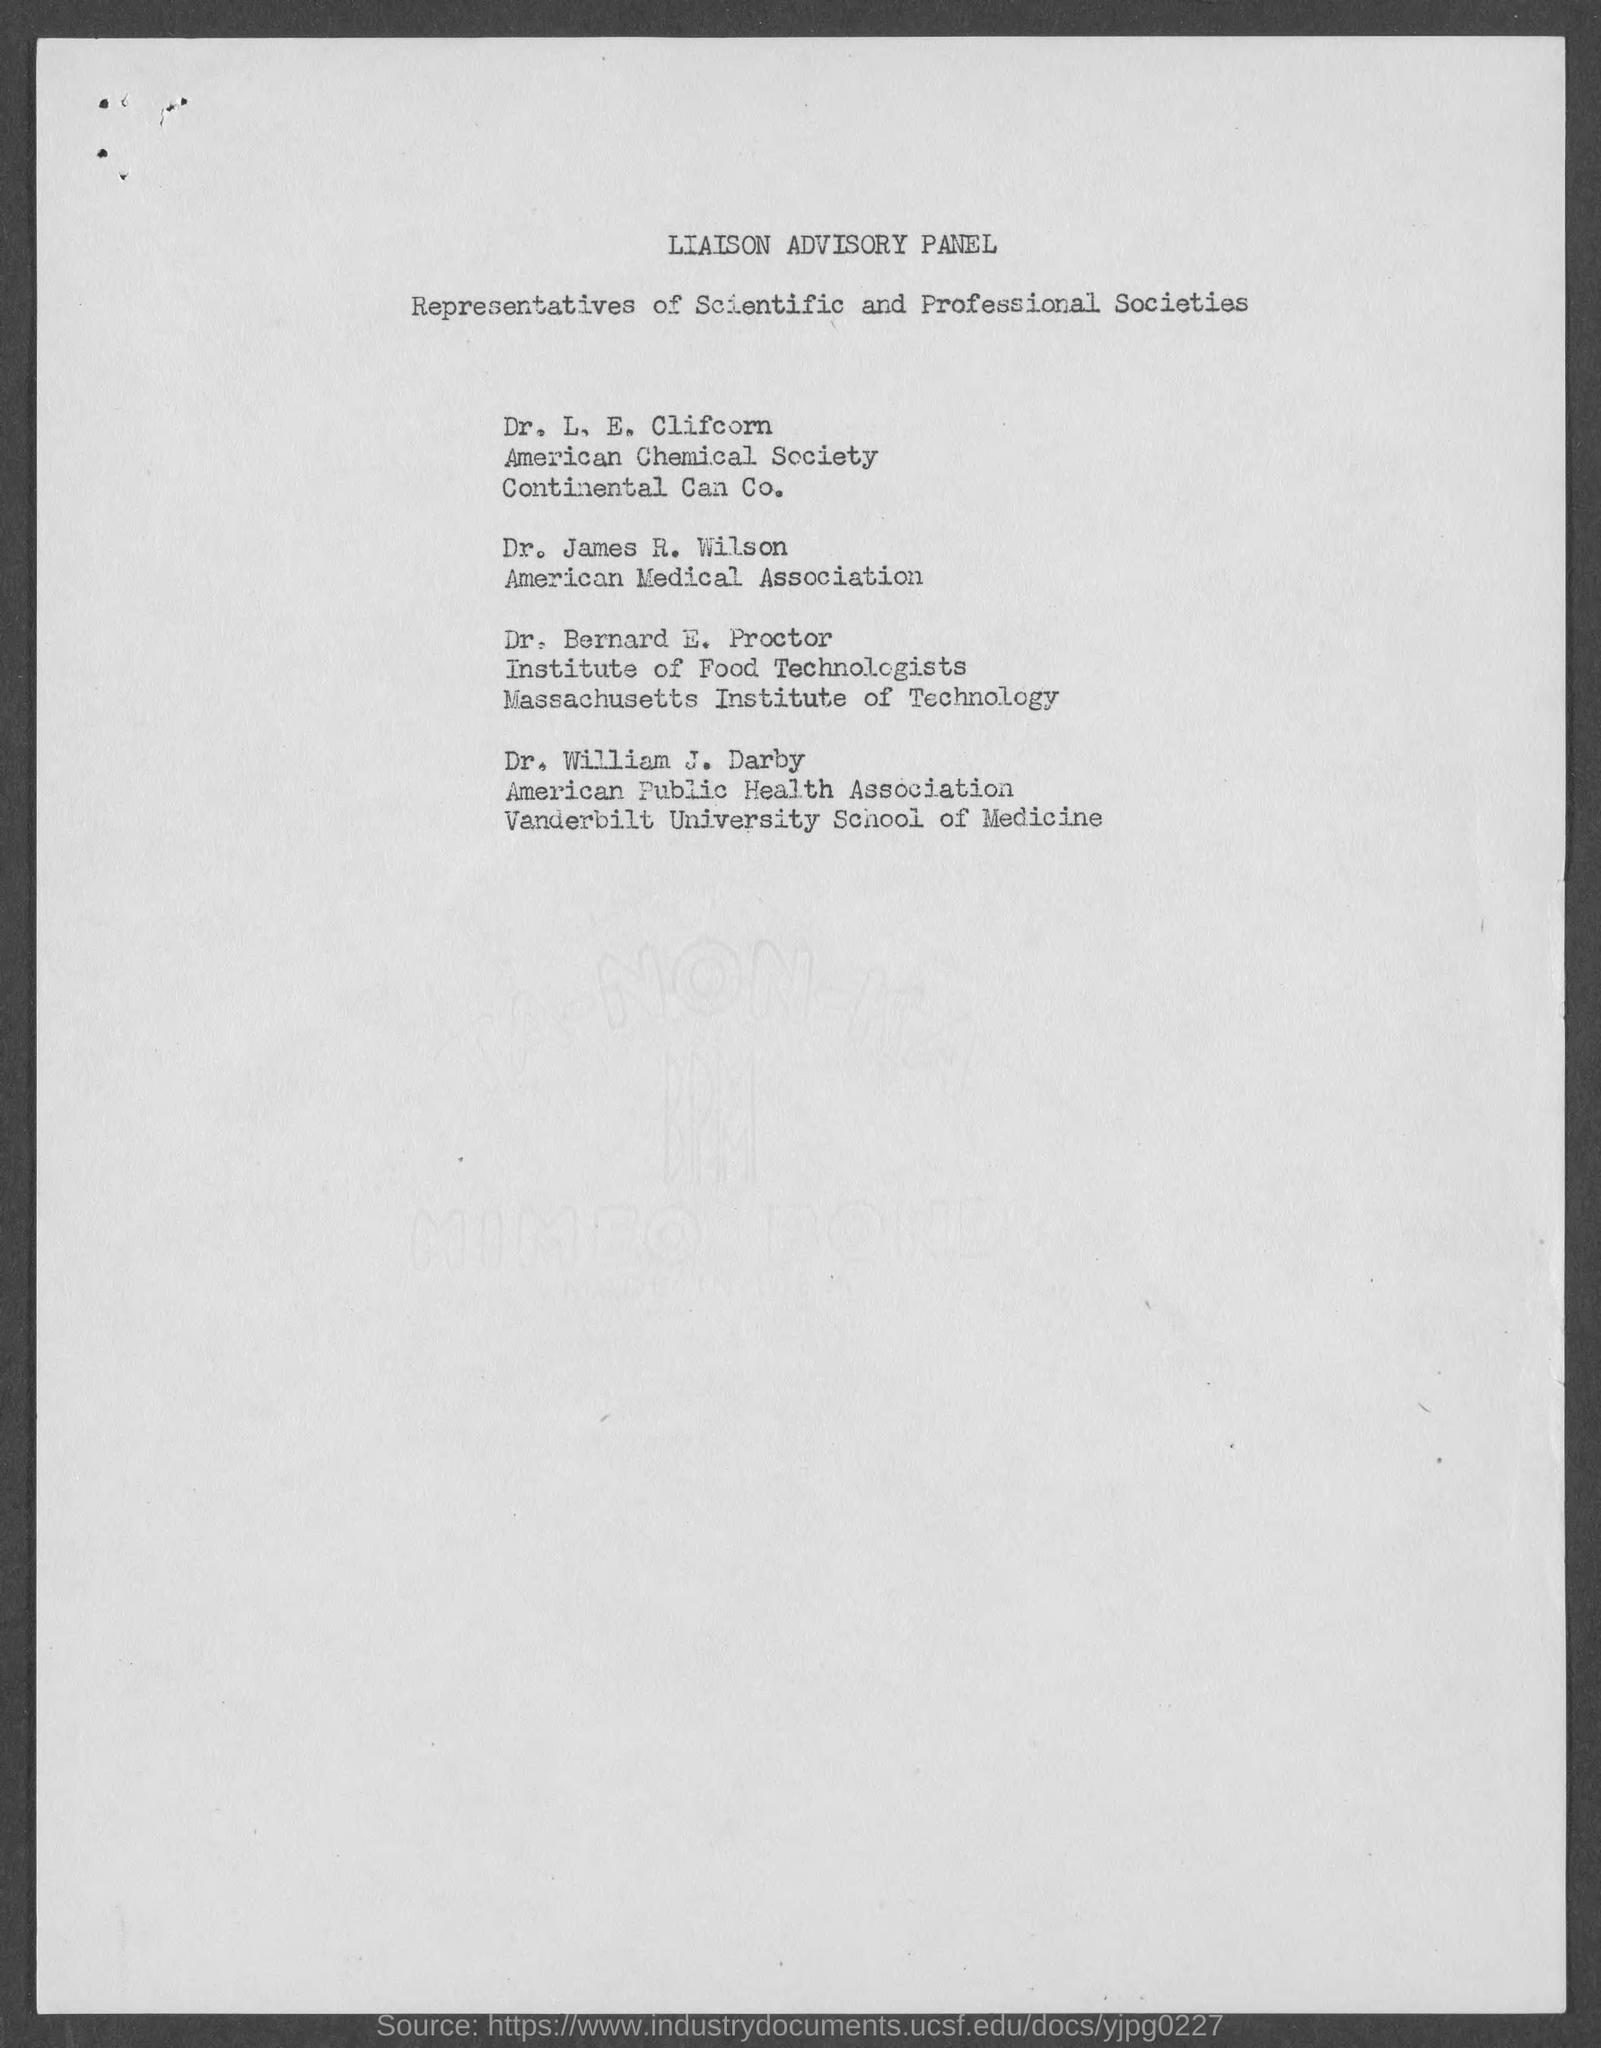Give some essential details in this illustration. The document lists representatives from scientific and professional societies. Dr. James R. Wilson, a member of the American Medical Association, is from the United States. 